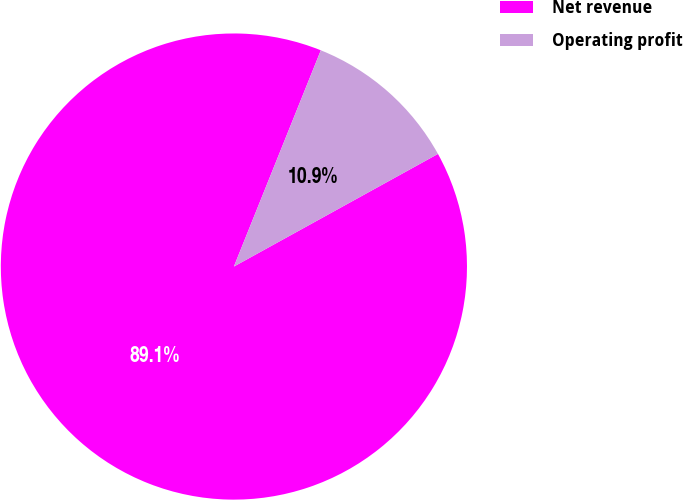Convert chart to OTSL. <chart><loc_0><loc_0><loc_500><loc_500><pie_chart><fcel>Net revenue<fcel>Operating profit<nl><fcel>89.11%<fcel>10.89%<nl></chart> 